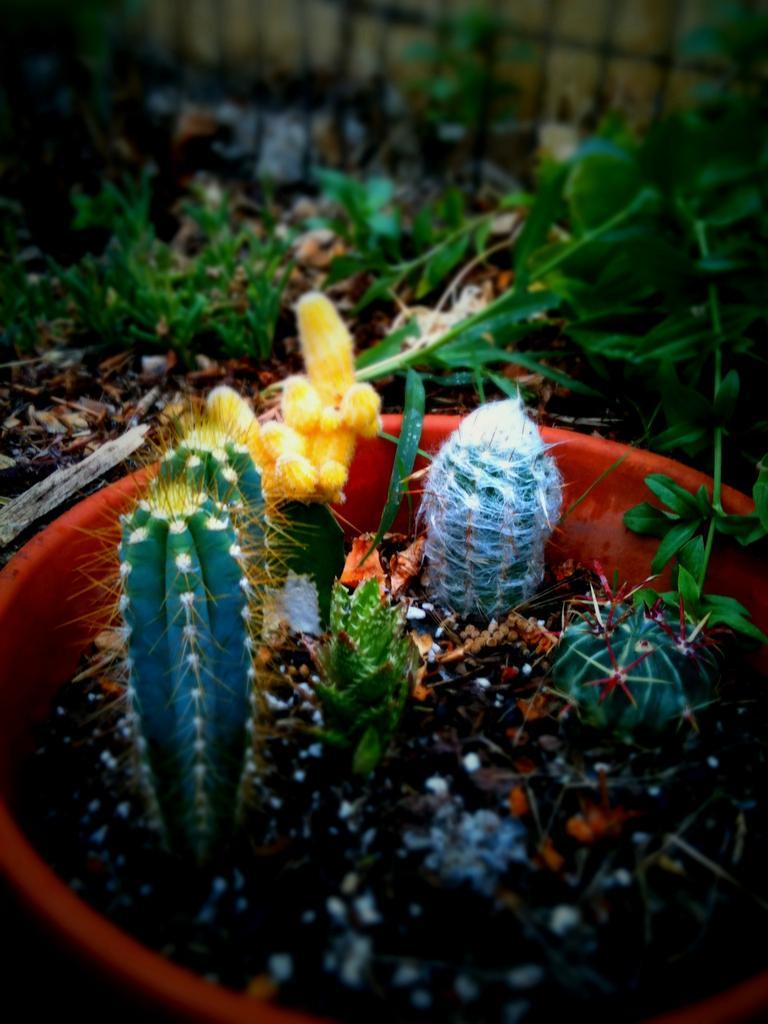Can you describe this image briefly? In this image we can see some cactus plants in a pot, there are some plants and in the background, we can see the wall. 